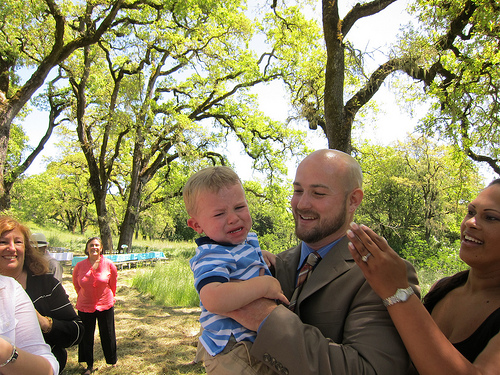<image>
Is the shirt on the person? No. The shirt is not positioned on the person. They may be near each other, but the shirt is not supported by or resting on top of the person. Where is the sky in relation to the tree? Is it behind the tree? Yes. From this viewpoint, the sky is positioned behind the tree, with the tree partially or fully occluding the sky. Is there a baby behind the lady? No. The baby is not behind the lady. From this viewpoint, the baby appears to be positioned elsewhere in the scene. Is there a kid behind the man? No. The kid is not behind the man. From this viewpoint, the kid appears to be positioned elsewhere in the scene. 